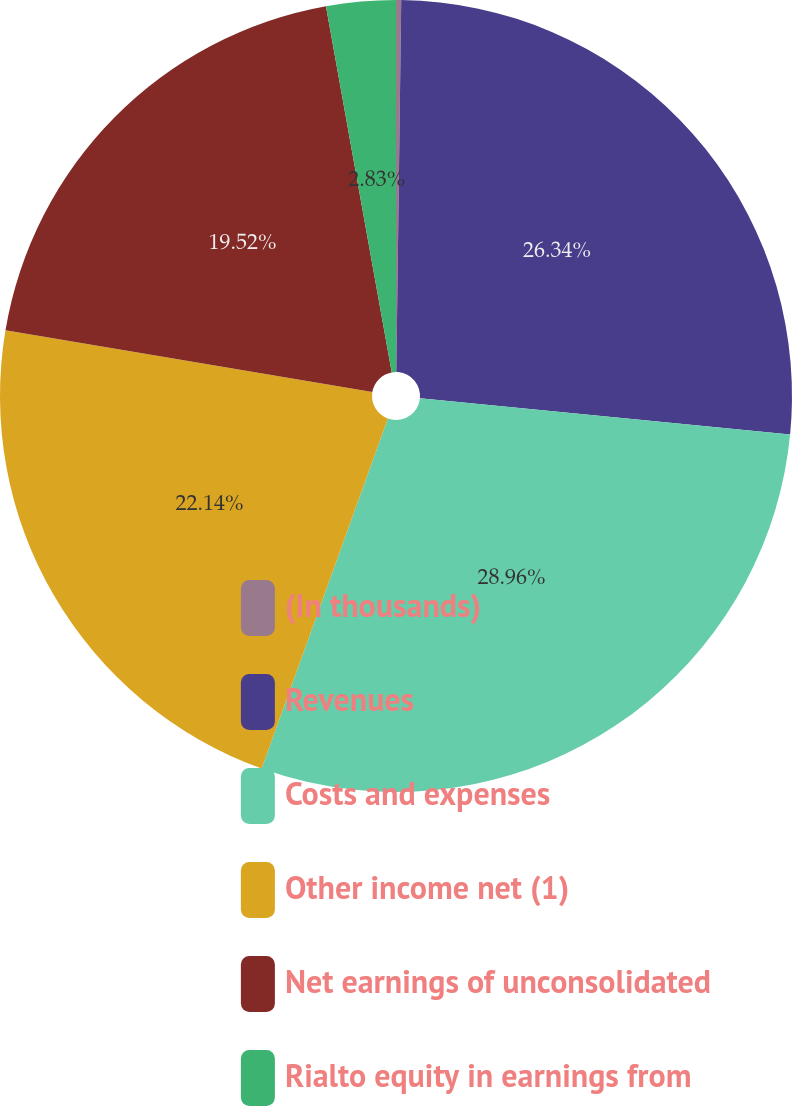<chart> <loc_0><loc_0><loc_500><loc_500><pie_chart><fcel>(In thousands)<fcel>Revenues<fcel>Costs and expenses<fcel>Other income net (1)<fcel>Net earnings of unconsolidated<fcel>Rialto equity in earnings from<nl><fcel>0.21%<fcel>26.34%<fcel>28.96%<fcel>22.14%<fcel>19.52%<fcel>2.83%<nl></chart> 